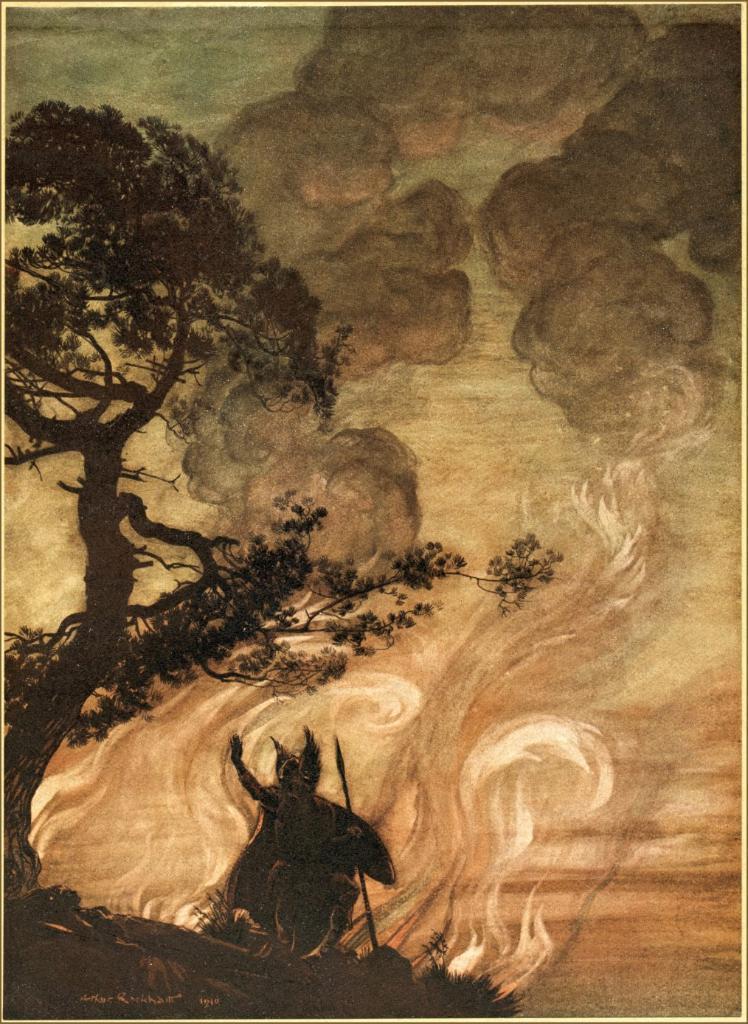In one or two sentences, can you explain what this image depicts? In this image I can see an art in which I can see a tree and a black colored object on the ground. In the background I can see the fire, some smoke and the sky. 